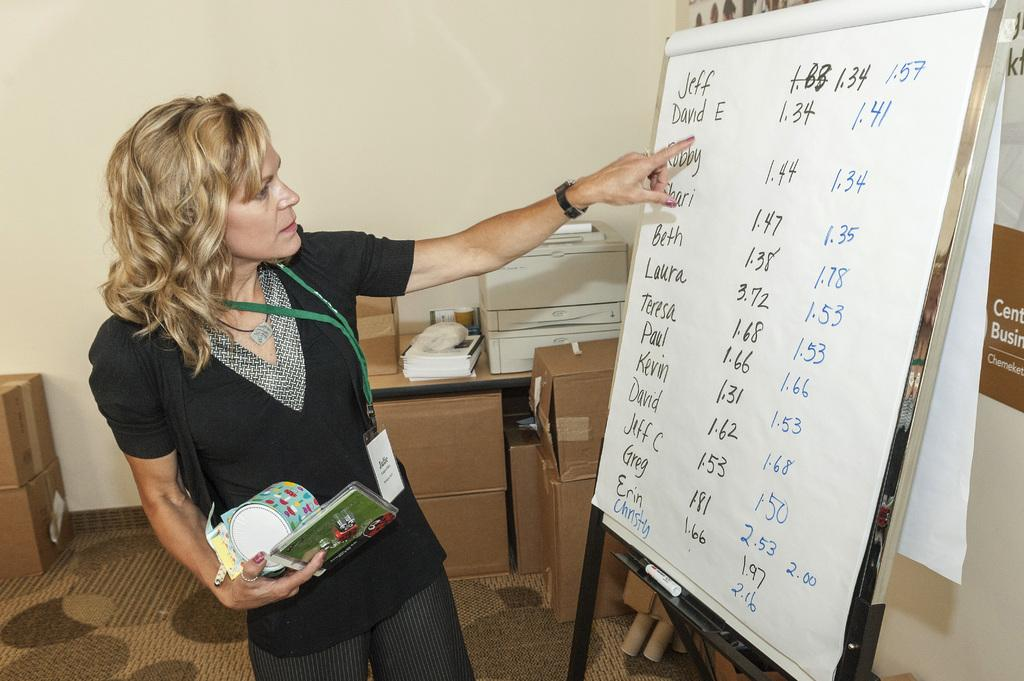<image>
Give a short and clear explanation of the subsequent image. The first name in a list on a large white paper is Jeff. 